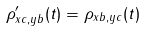Convert formula to latex. <formula><loc_0><loc_0><loc_500><loc_500>\rho ^ { \prime } _ { x c , y b } ( t ) = \rho _ { x b , y c } ( t )</formula> 